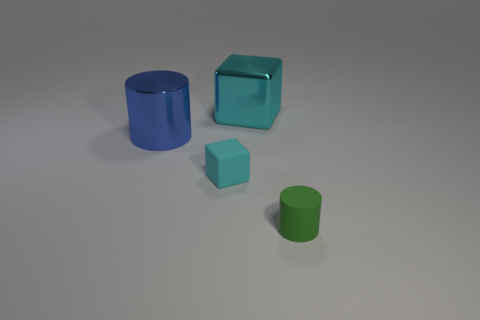There is a metal cube that is the same color as the rubber cube; what size is it?
Offer a very short reply. Large. The large object that is the same color as the small matte cube is what shape?
Ensure brevity in your answer.  Cube. Is there any other thing that has the same color as the tiny rubber block?
Make the answer very short. Yes. There is a large shiny object that is on the right side of the small cyan matte object; is it the same color as the tiny thing that is behind the green object?
Give a very brief answer. Yes. There is a tiny cube; is its color the same as the large thing that is on the right side of the small block?
Give a very brief answer. Yes. Is the shape of the green thing the same as the big blue object?
Provide a succinct answer. Yes. How many cylinders are left of the tiny rubber thing in front of the cyan matte cube?
Provide a short and direct response. 1. What is the shape of the other thing that is the same material as the green thing?
Give a very brief answer. Cube. How many gray things are large metallic cylinders or small blocks?
Offer a terse response. 0. Is there a green rubber cylinder in front of the cube on the left side of the big thing that is behind the blue object?
Provide a succinct answer. Yes. 